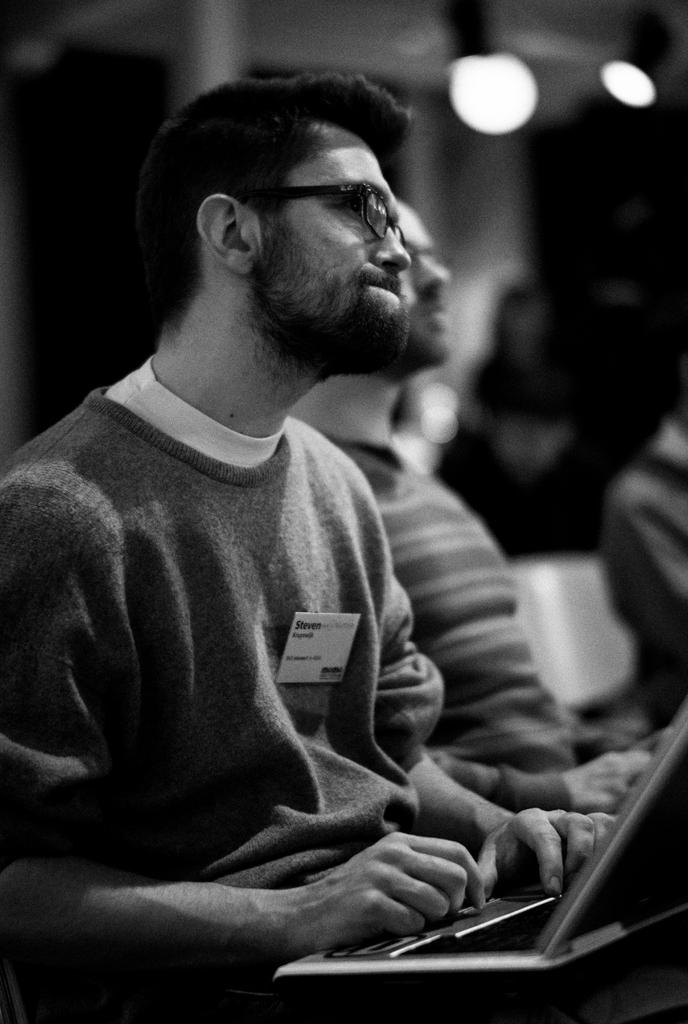What is the color scheme of the image? The image is black and white. What is the person in the image doing? The person is sitting and holding a laptop in the image. Can you describe the background of the image? There are other persons in the background of the image. How many spiders can be seen crawling on the person's laptop in the image? There are no spiders visible on the laptop in the image. What mathematical operation is being performed by the person in the image? The image does not provide any information about the person performing a mathematical operation. 